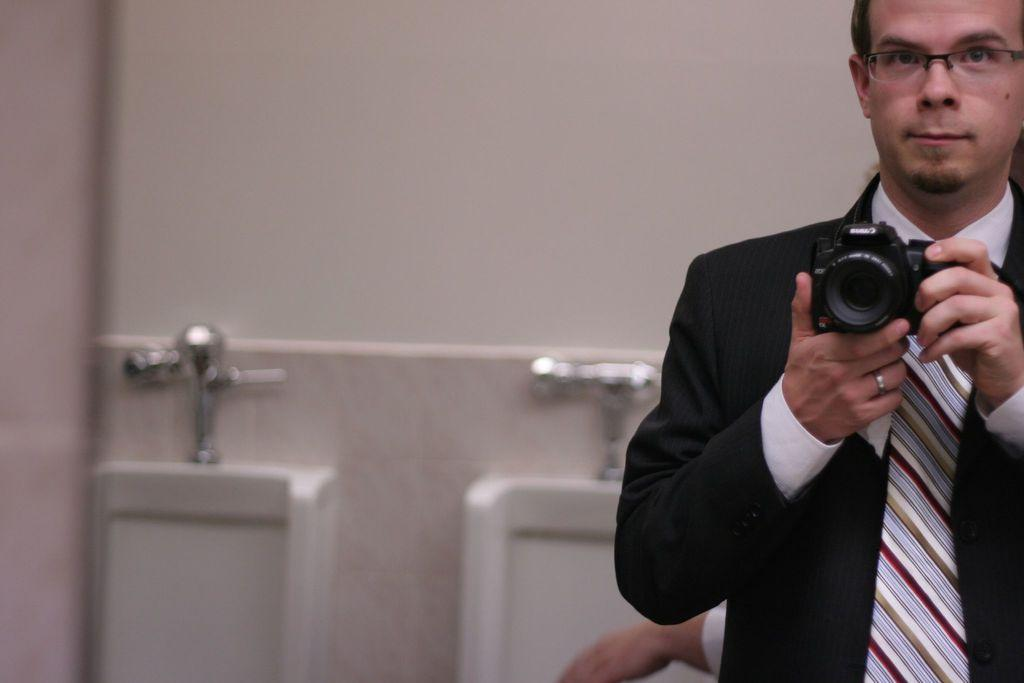What is the man in the image wearing? The man is wearing a black blazer, a white shirt, and a striped tie. What is the man holding in his hand? The man is holding a camera in his hand. What is the man doing with the camera? The man is clicking a picture. Can you describe the person in the background of the image? There is a person in the background of the image, but no specific details are provided. What type of blood is visible on the man's shirt in the image? There is no blood visible on the man's shirt in the image. What type of pleasure can be seen on the man's face while taking the picture? The man's facial expression is not described in the facts, so it is not possible to determine if he is experiencing pleasure or any other emotion. 